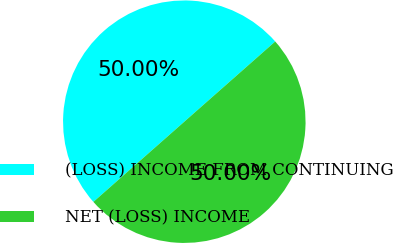<chart> <loc_0><loc_0><loc_500><loc_500><pie_chart><fcel>(LOSS) INCOME FROM CONTINUING<fcel>NET (LOSS) INCOME<nl><fcel>50.0%<fcel>50.0%<nl></chart> 